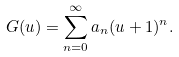<formula> <loc_0><loc_0><loc_500><loc_500>G ( u ) = \sum _ { n = 0 } ^ { \infty } a _ { n } ( u + 1 ) ^ { n } .</formula> 